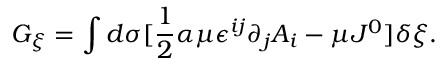Convert formula to latex. <formula><loc_0><loc_0><loc_500><loc_500>G _ { \xi } = \int d \sigma [ \frac { 1 } { 2 } \alpha \mu \epsilon ^ { i j } \partial _ { j } A _ { i } - \mu J ^ { 0 } ] \delta \xi .</formula> 